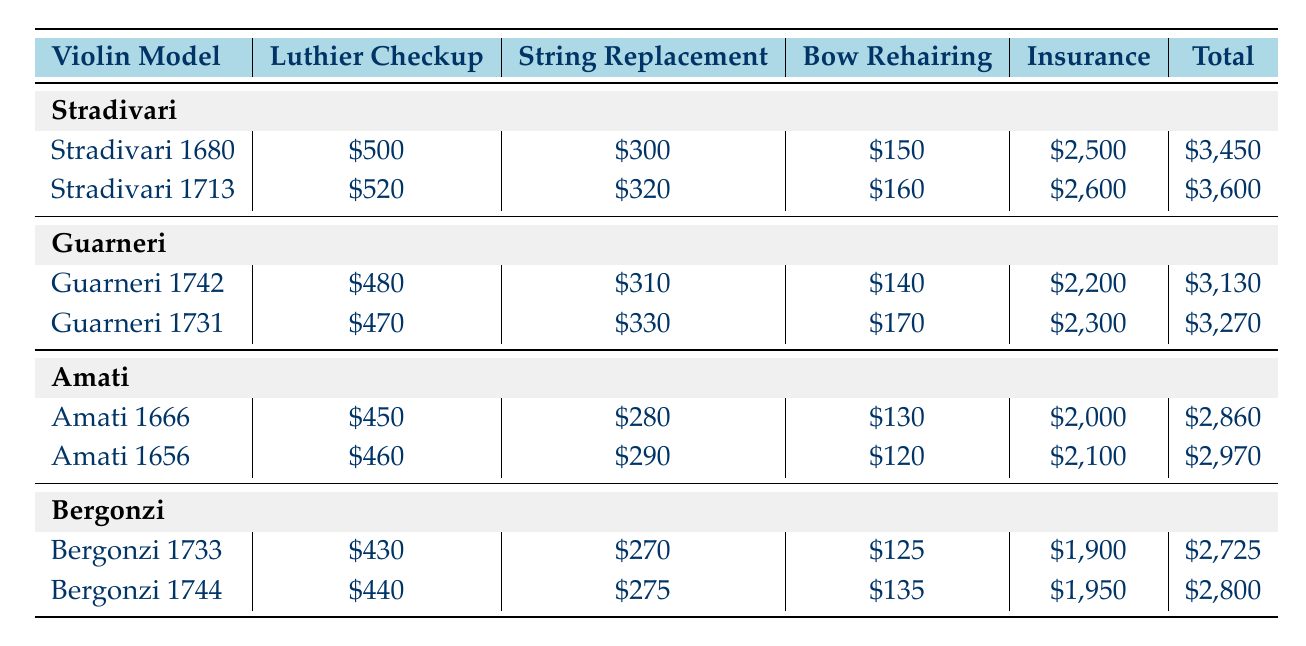What is the total annual maintenance cost for Stradivari 1680? The total maintenance cost is directly given in the table under the "Total" column for the Stradivari 1680 model, which is listed as 3450.
Answer: 3450 Which model has the highest luthier checkup cost? By checking the "Luthier Checkup" column, Stradivari 1713 has the highest cost, listed as 520.
Answer: 520 What is the combined total annual maintenance cost for all models from the Amati manufacturer? To find the combined total, we add the total costs for the two Amati models: 2860 (for Amati 1666) + 2970 (for Amati 1656) = 5830.
Answer: 5830 Is the insurance cost for the Guarneri 1742 lower than for the Amati 1666? Looking at the insurance costs, Guarneri 1742 has an insurance cost of 2200, while Amati 1666 has 2000. Since 2200 is greater than 2000, the statement is false.
Answer: No What is the average total maintenance cost for all the Guarneri models combined? The total costs for Guarneri models are 3130 (Guarneri 1742) and 3270 (Guarneri 1731). Adding these gives us 6400, and dividing by 2 (number of models) gives 3200 as the average.
Answer: 3200 Which manufacturer has the lowest total maintenance cost for its highest-cost model? Reviewing the table, Bergonzi 1744 is the highest-cost model under Bergonzi with a total of 2800, and this is the lowest among all highest-cost models across manufacturers: 3600 (Stradivari) and 3270 (Guarneri).
Answer: Bergonzi What are the annual costs for bow rehiring for all violin models from the Stradivari manufacturer? The costs for bow rehiring from Stradivari models are: 150 (Stradivari 1680) and 160 (Stradivari 1713). These values are listed in the "Bow Rehairing" column.
Answer: 150, 160 Is the total maintenance cost for the lowest-cost Bergonzi model less than 2900? The total for the lowest-cost Bergonzi model (Bergonzi 1733) is 2725 as shown in the table. Since 2725 is less than 2900, the answer is yes.
Answer: Yes What is the difference in total costs between the highest and lowest total maintenance costs across all manufacturers? The highest total is 3600 (Stradivari 1713) and the lowest total is 2725 (Bergonzi 1733). The difference is calculated as 3600 - 2725 = 875.
Answer: 875 